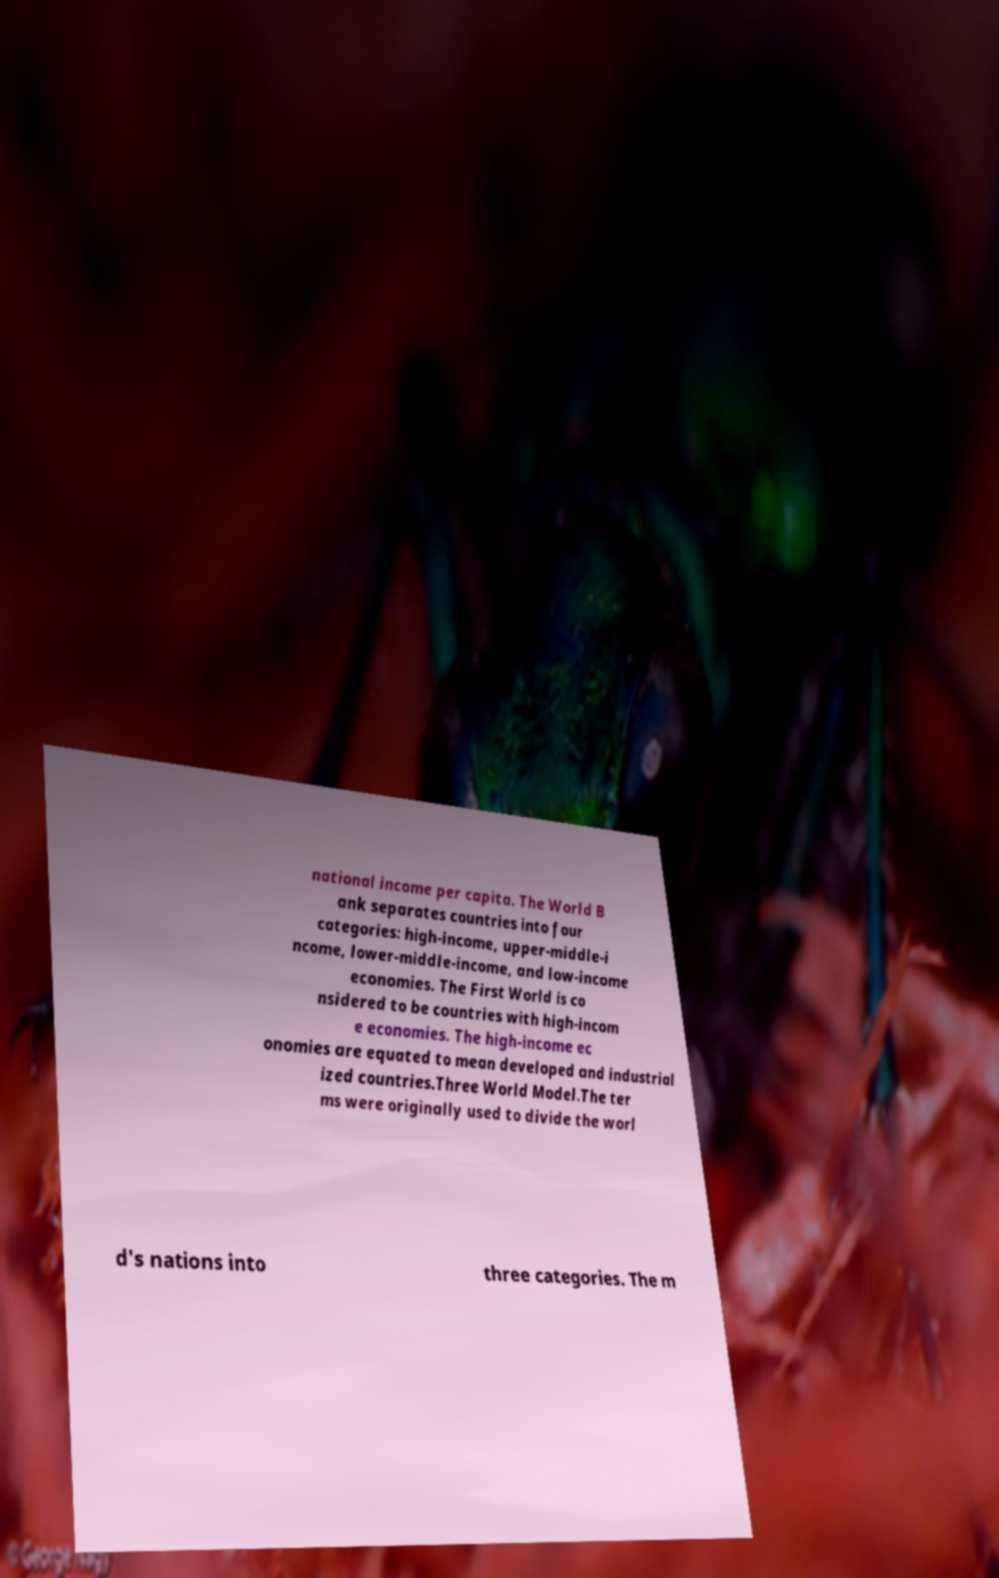Please identify and transcribe the text found in this image. national income per capita. The World B ank separates countries into four categories: high-income, upper-middle-i ncome, lower-middle-income, and low-income economies. The First World is co nsidered to be countries with high-incom e economies. The high-income ec onomies are equated to mean developed and industrial ized countries.Three World Model.The ter ms were originally used to divide the worl d's nations into three categories. The m 